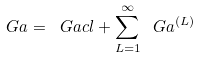Convert formula to latex. <formula><loc_0><loc_0><loc_500><loc_500>\ G a = \ G a c l + \sum _ { L = 1 } ^ { \infty } \ G a ^ { ( L ) }</formula> 